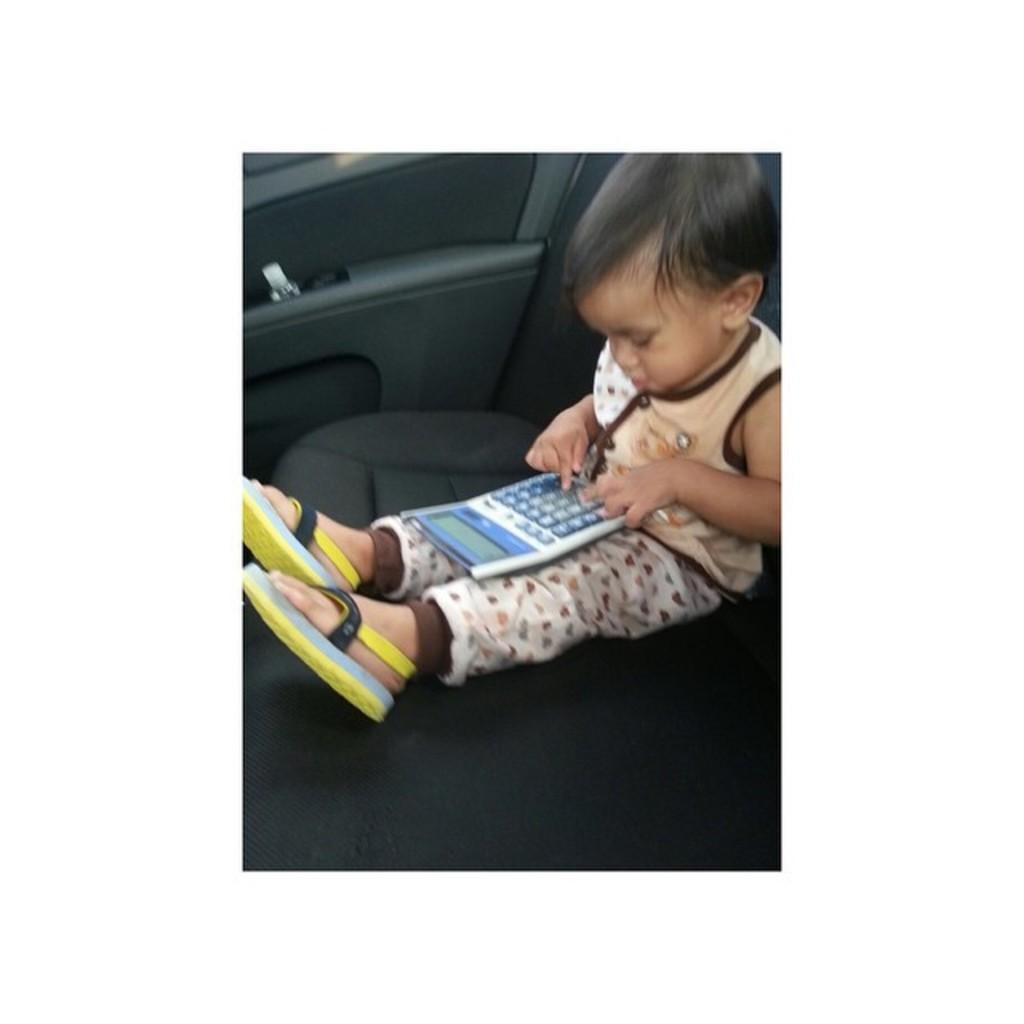How would you summarize this image in a sentence or two? In this image there is a kid sitting on the seat of a vehicle. The kid is having a calculator on his lap. He is pressing the buttons on the calculator. He is wearing some footwear. 